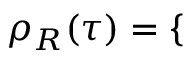<formula> <loc_0><loc_0><loc_500><loc_500>\rho _ { R } ( \tau ) = \left \{ \begin{array} { r l r l } \end{array}</formula> 